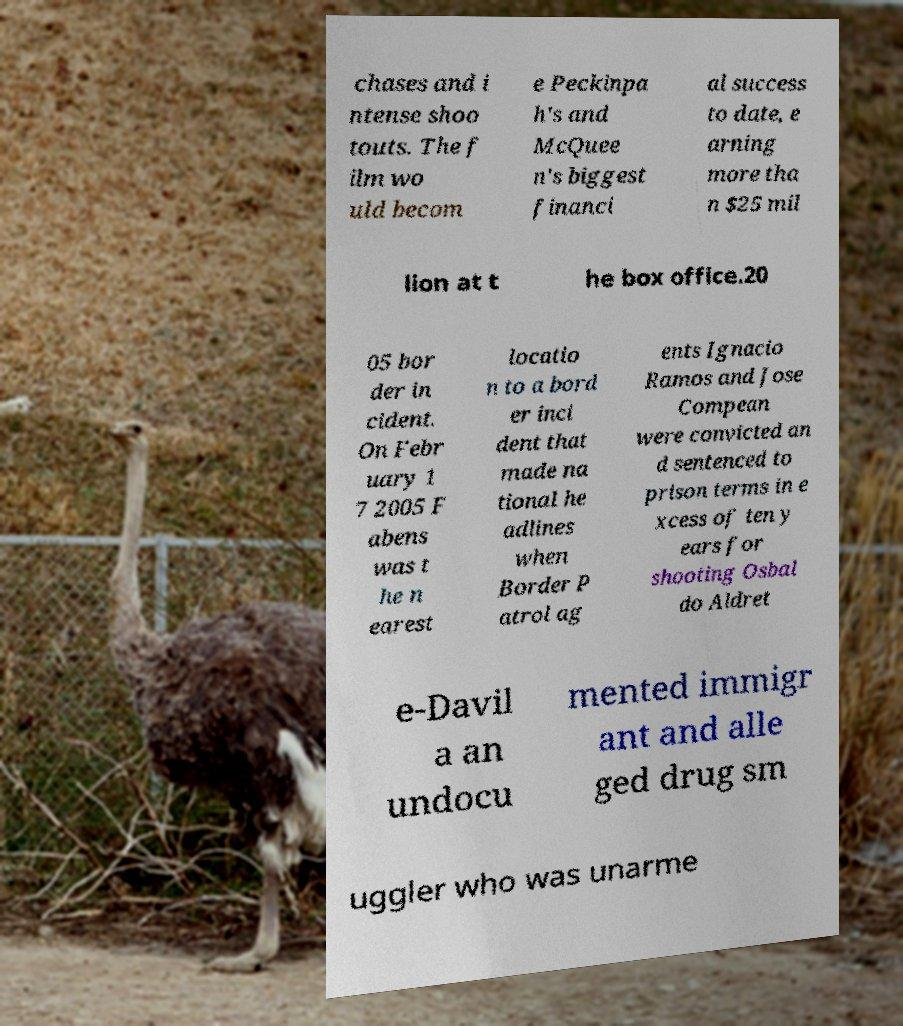Please identify and transcribe the text found in this image. chases and i ntense shoo touts. The f ilm wo uld becom e Peckinpa h's and McQuee n's biggest financi al success to date, e arning more tha n $25 mil lion at t he box office.20 05 bor der in cident. On Febr uary 1 7 2005 F abens was t he n earest locatio n to a bord er inci dent that made na tional he adlines when Border P atrol ag ents Ignacio Ramos and Jose Compean were convicted an d sentenced to prison terms in e xcess of ten y ears for shooting Osbal do Aldret e-Davil a an undocu mented immigr ant and alle ged drug sm uggler who was unarme 